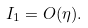Convert formula to latex. <formula><loc_0><loc_0><loc_500><loc_500>I _ { 1 } = O ( \eta ) .</formula> 